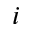Convert formula to latex. <formula><loc_0><loc_0><loc_500><loc_500>i</formula> 